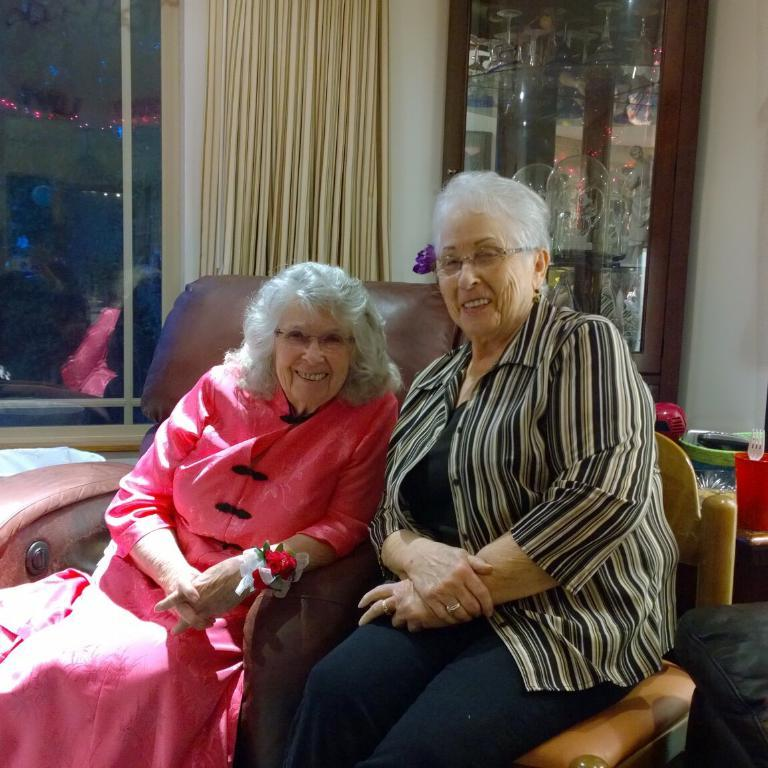How many women are sitting in chairs in the image? There are two women sitting in chairs in the image. What can be seen in the background of the image? There is a cupboard with items, a curtain associated with a window, and a window in the background. What might be the purpose of the window in the image? The window in the background might provide natural light or a view of the outside. What type of group activity are the women participating in with their fathers and horses in the image? There are no fathers or horses present in the image; it only features two women sitting in chairs and details about the background. 